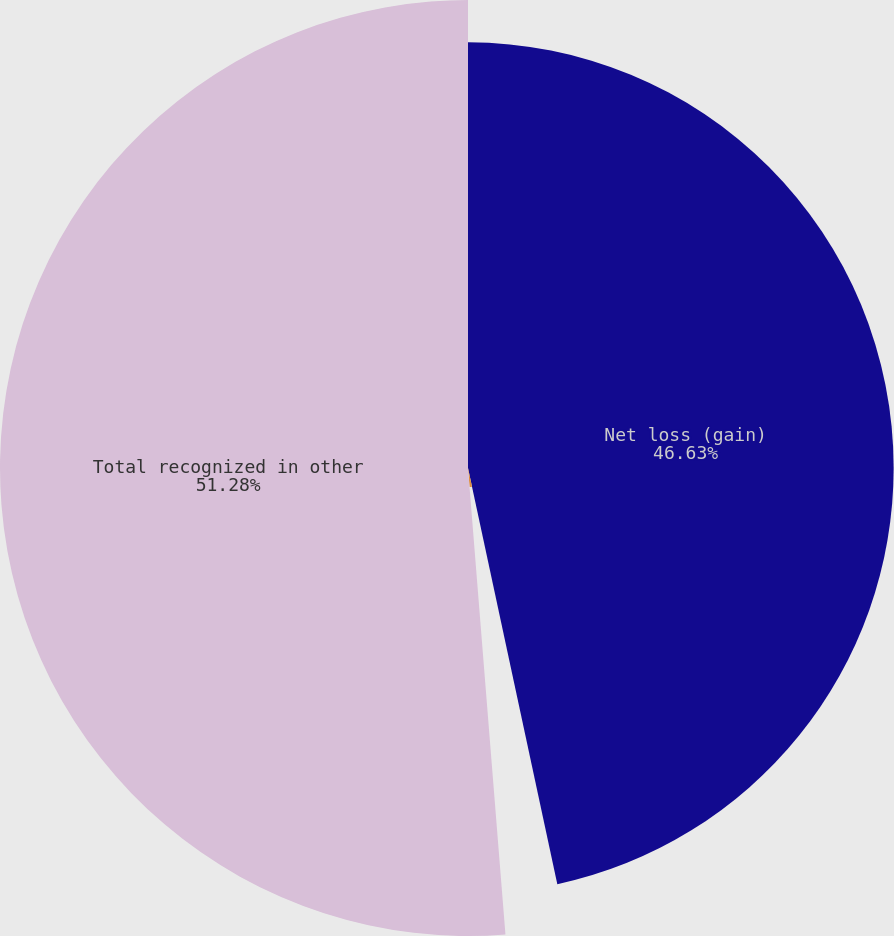Convert chart to OTSL. <chart><loc_0><loc_0><loc_500><loc_500><pie_chart><fcel>Net loss (gain)<fcel>Amortization of net loss<fcel>Total recognized in other<nl><fcel>46.63%<fcel>2.09%<fcel>51.27%<nl></chart> 